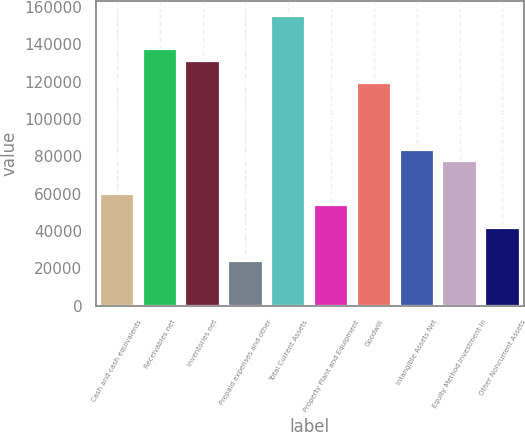Convert chart to OTSL. <chart><loc_0><loc_0><loc_500><loc_500><bar_chart><fcel>Cash and cash equivalents<fcel>Receivables net<fcel>Inventories net<fcel>Prepaid expenses and other<fcel>Total Current Assets<fcel>Property Plant and Equipment<fcel>Goodwill<fcel>Intangible Assets Net<fcel>Equity Method Investment in<fcel>Other Noncurrent Assets<nl><fcel>59672<fcel>137243<fcel>131276<fcel>23870<fcel>155144<fcel>53705<fcel>119342<fcel>83540<fcel>77573<fcel>41771<nl></chart> 